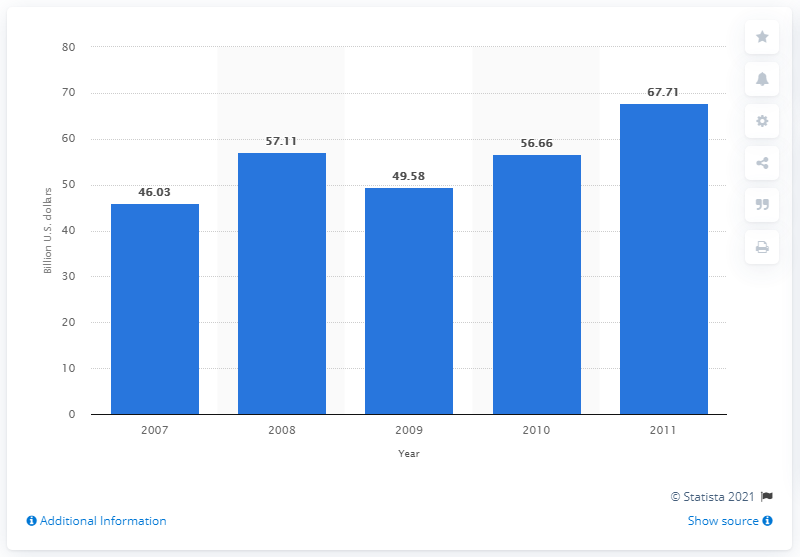Give some essential details in this illustration. In 2008, the total consumer spending in Kazakhstan was 56.66. 